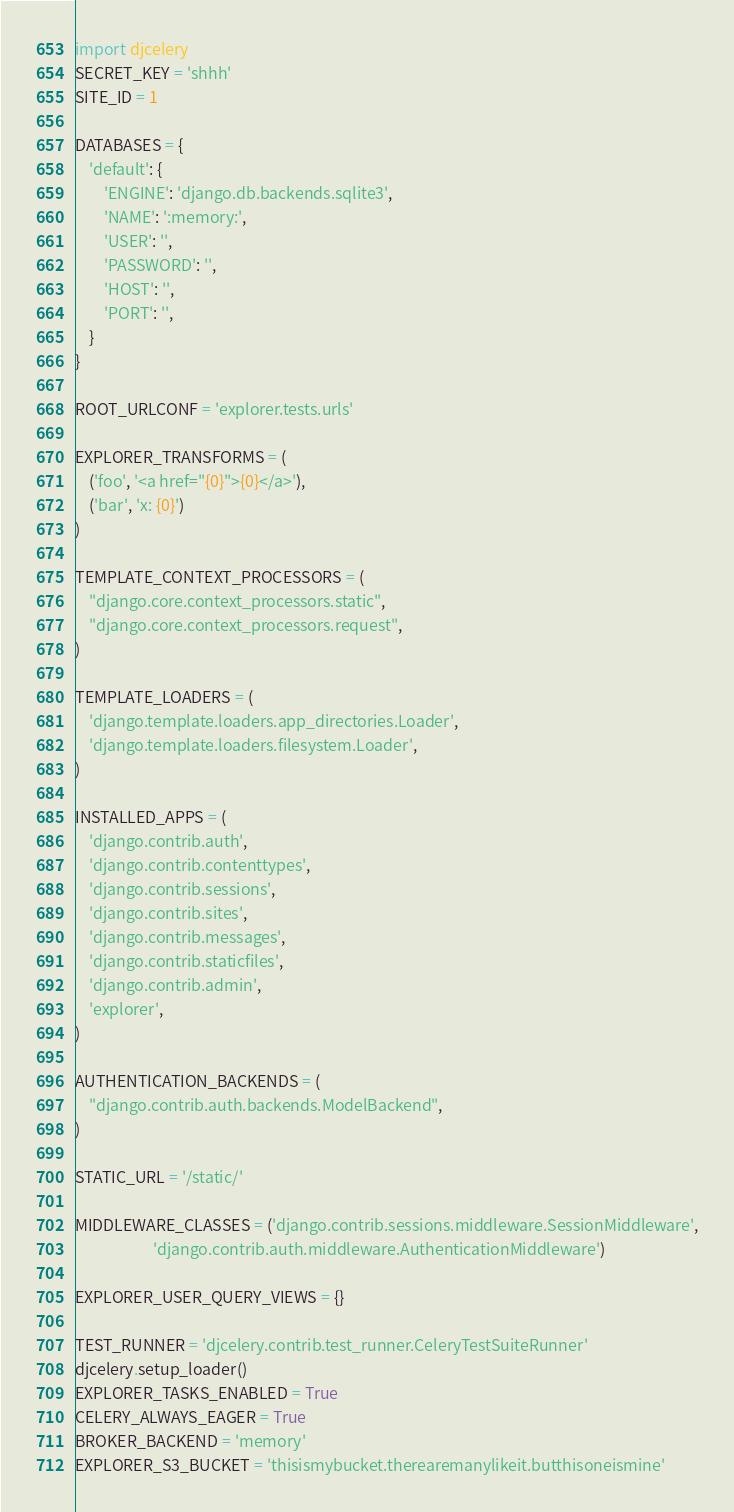<code> <loc_0><loc_0><loc_500><loc_500><_Python_>import djcelery
SECRET_KEY = 'shhh'
SITE_ID = 1

DATABASES = {
    'default': {
        'ENGINE': 'django.db.backends.sqlite3',
        'NAME': ':memory:',
        'USER': '',
        'PASSWORD': '',
        'HOST': '',
        'PORT': '',
    }
}

ROOT_URLCONF = 'explorer.tests.urls'

EXPLORER_TRANSFORMS = (
    ('foo', '<a href="{0}">{0}</a>'),
    ('bar', 'x: {0}')
)

TEMPLATE_CONTEXT_PROCESSORS = (
    "django.core.context_processors.static",
    "django.core.context_processors.request",
)

TEMPLATE_LOADERS = (
    'django.template.loaders.app_directories.Loader',
    'django.template.loaders.filesystem.Loader',
)

INSTALLED_APPS = (
    'django.contrib.auth',
    'django.contrib.contenttypes',
    'django.contrib.sessions',
    'django.contrib.sites',
    'django.contrib.messages',
    'django.contrib.staticfiles',
    'django.contrib.admin',
    'explorer',
)

AUTHENTICATION_BACKENDS = (
    "django.contrib.auth.backends.ModelBackend",
)

STATIC_URL = '/static/'

MIDDLEWARE_CLASSES = ('django.contrib.sessions.middleware.SessionMiddleware',
                      'django.contrib.auth.middleware.AuthenticationMiddleware')

EXPLORER_USER_QUERY_VIEWS = {}

TEST_RUNNER = 'djcelery.contrib.test_runner.CeleryTestSuiteRunner'
djcelery.setup_loader()
EXPLORER_TASKS_ENABLED = True
CELERY_ALWAYS_EAGER = True
BROKER_BACKEND = 'memory'
EXPLORER_S3_BUCKET = 'thisismybucket.therearemanylikeit.butthisoneismine'
</code> 